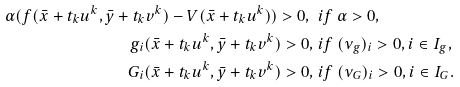<formula> <loc_0><loc_0><loc_500><loc_500>\alpha ( f ( \bar { x } + t _ { k } u ^ { k } , \bar { y } + t _ { k } v ^ { k } ) - V ( \bar { x } + t _ { k } u ^ { k } ) ) > 0 , \ & i f \ \alpha > 0 , \\ g _ { i } ( \bar { x } + t _ { k } u ^ { k } , \bar { y } + t _ { k } v ^ { k } ) > 0 , \ & i f \ ( \nu _ { g } ) _ { i } > 0 , i \in I _ { g } , \\ G _ { i } ( \bar { x } + t _ { k } u ^ { k } , \bar { y } + t _ { k } v ^ { k } ) > 0 , \ & i f \ ( \nu _ { G } ) _ { i } > 0 , i \in I _ { G } .</formula> 